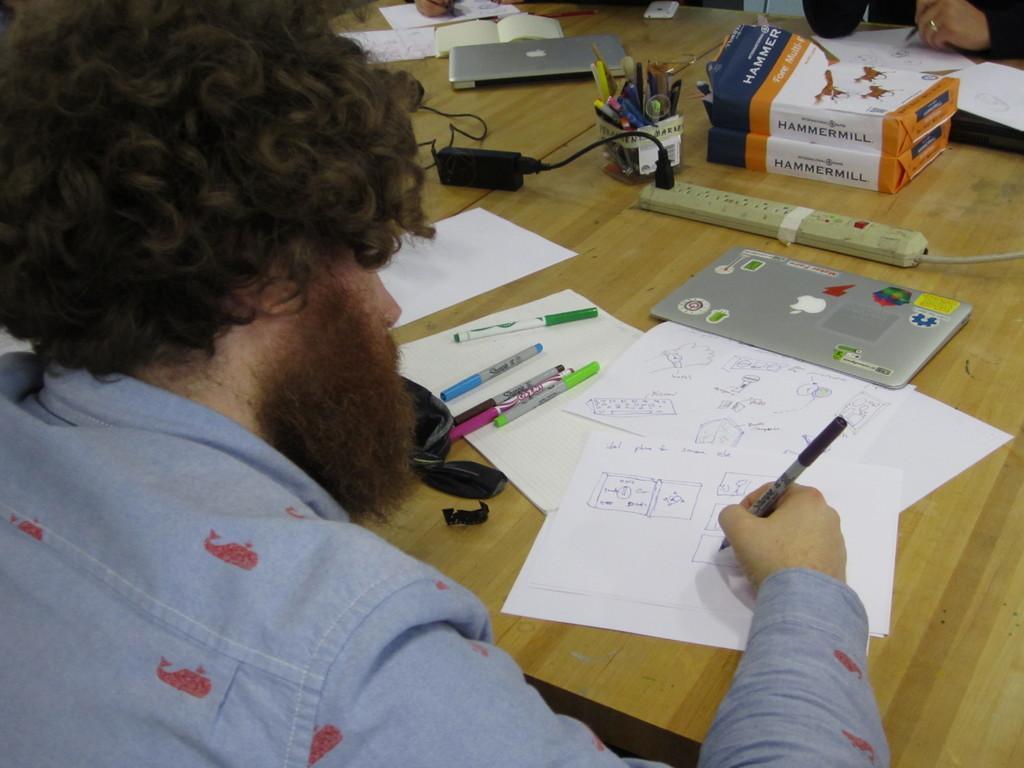Could you give a brief overview of what you see in this image? There is a person holding a pen. In front of him there is a table. On that there are papers, pens, extension board, packets, laptops and many other things. 